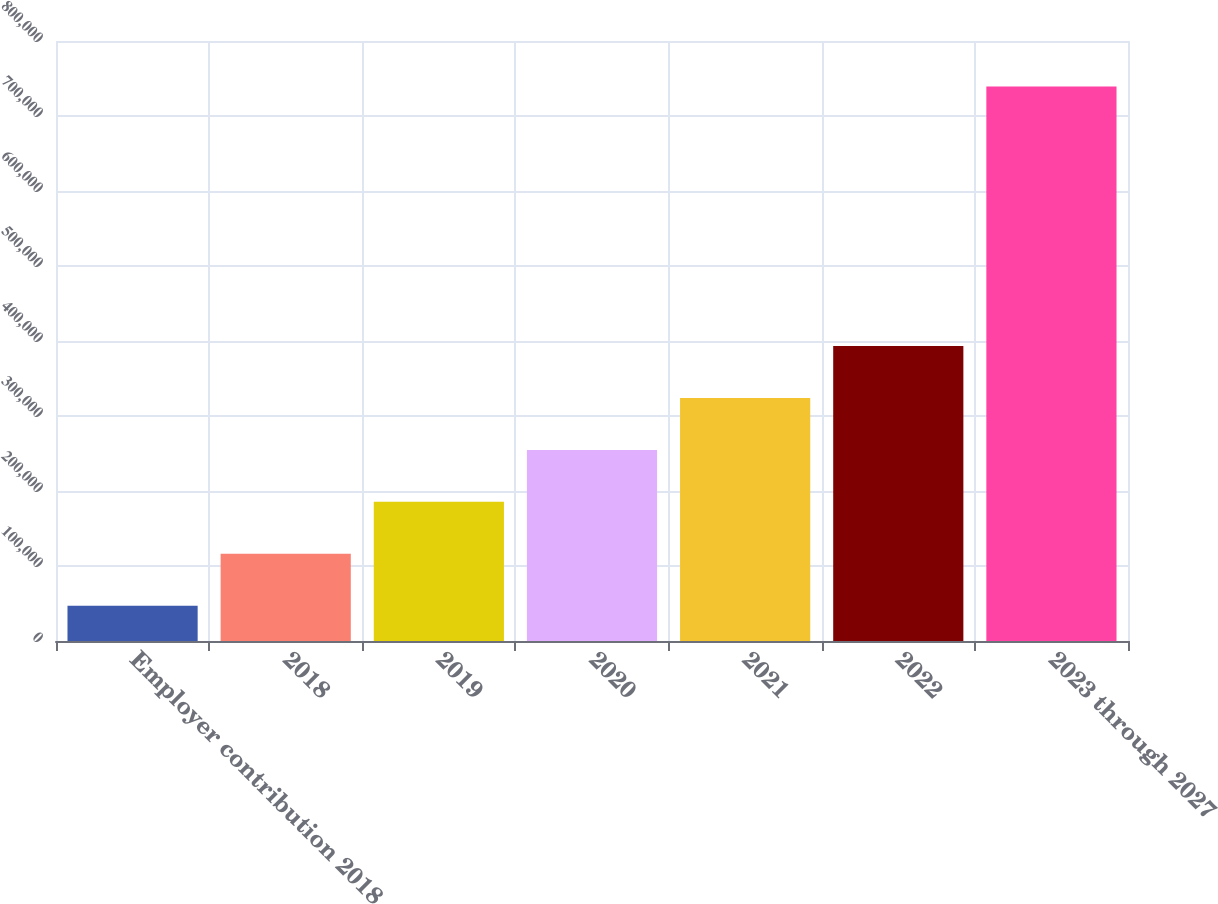Convert chart. <chart><loc_0><loc_0><loc_500><loc_500><bar_chart><fcel>Employer contribution 2018<fcel>2018<fcel>2019<fcel>2020<fcel>2021<fcel>2022<fcel>2023 through 2027<nl><fcel>47038<fcel>116326<fcel>185563<fcel>254800<fcel>324036<fcel>393273<fcel>739406<nl></chart> 